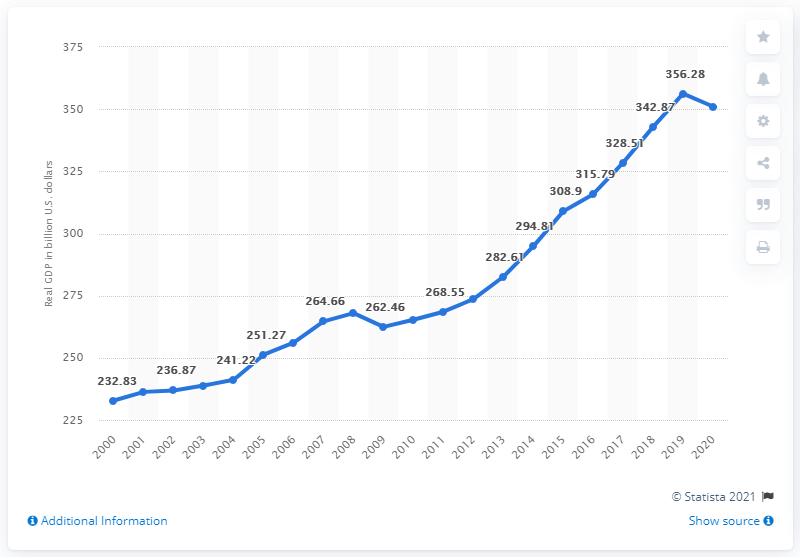Specify some key components in this picture. The Gross Domestic Product, or GDP, of Colorado in the previous year was 356.28 billion dollars. The Gross Domestic Product (GDP) of Colorado in 2020 was 351.07 billion dollars. 